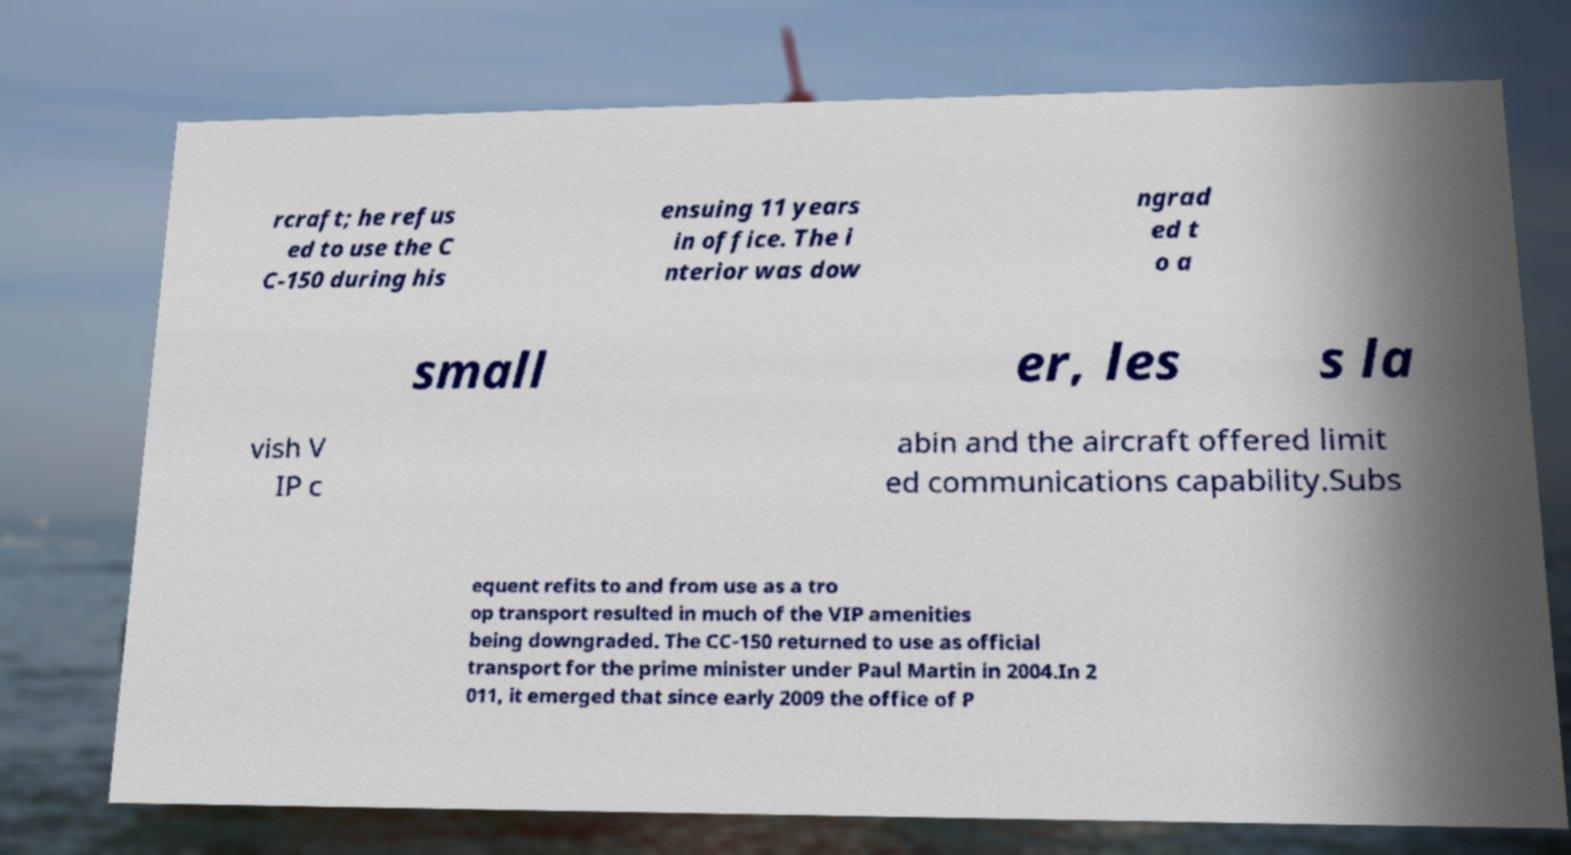Could you assist in decoding the text presented in this image and type it out clearly? rcraft; he refus ed to use the C C-150 during his ensuing 11 years in office. The i nterior was dow ngrad ed t o a small er, les s la vish V IP c abin and the aircraft offered limit ed communications capability.Subs equent refits to and from use as a tro op transport resulted in much of the VIP amenities being downgraded. The CC-150 returned to use as official transport for the prime minister under Paul Martin in 2004.In 2 011, it emerged that since early 2009 the office of P 